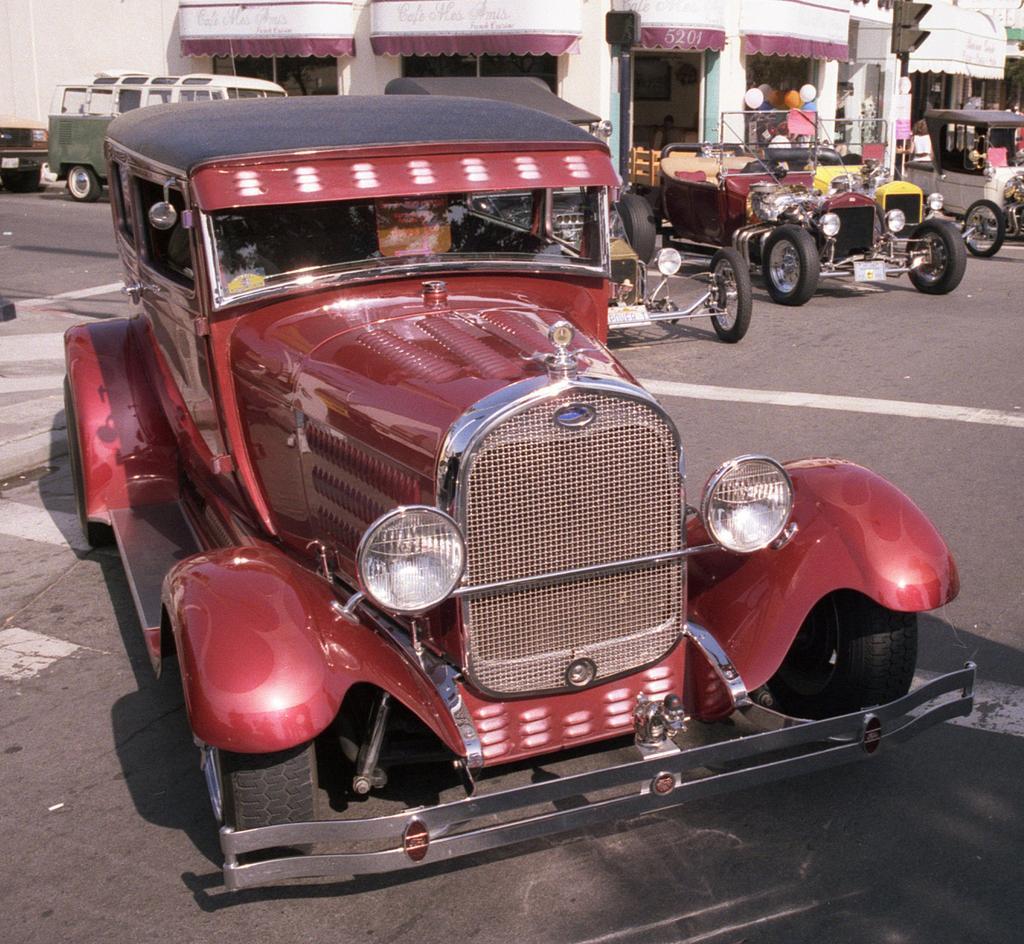Can you describe this image briefly? This is the picture of a road. In this image there are vehicles on the road. At the back there is a building and there are balloons on the vehicle and there are poles on the footpath. At the bottom there is a road. 